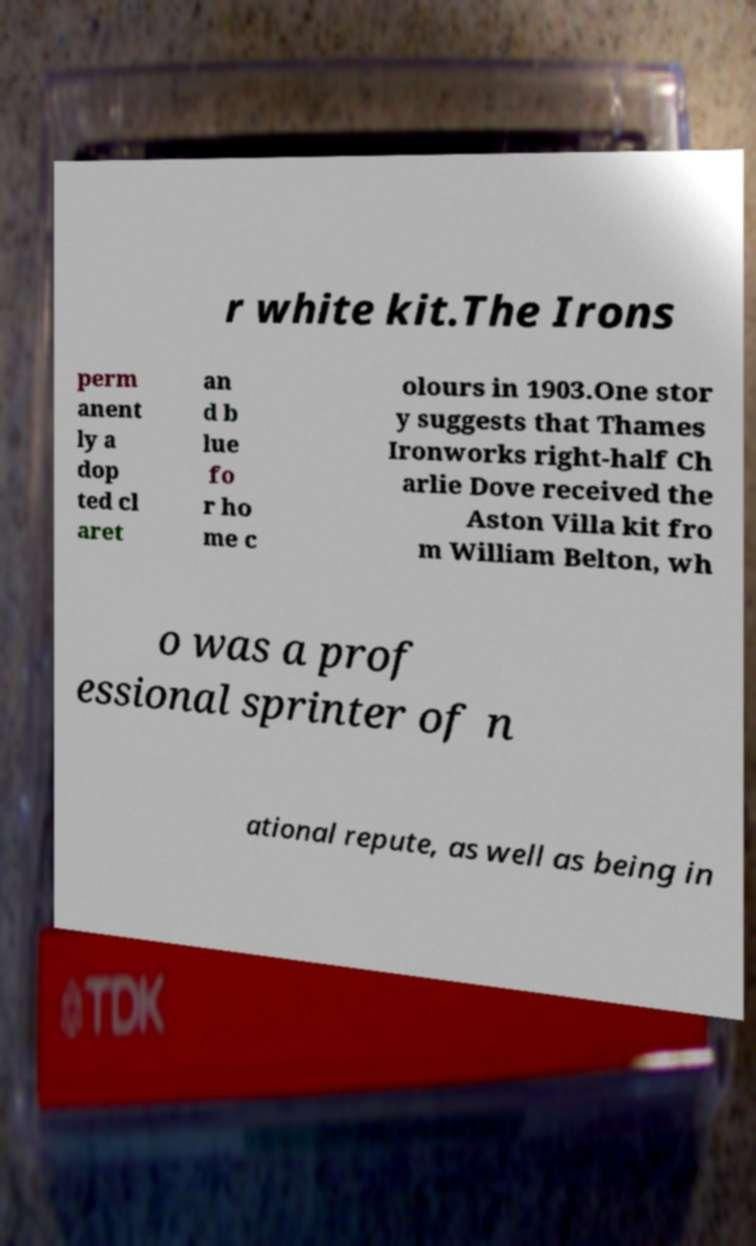What messages or text are displayed in this image? I need them in a readable, typed format. r white kit.The Irons perm anent ly a dop ted cl aret an d b lue fo r ho me c olours in 1903.One stor y suggests that Thames Ironworks right-half Ch arlie Dove received the Aston Villa kit fro m William Belton, wh o was a prof essional sprinter of n ational repute, as well as being in 